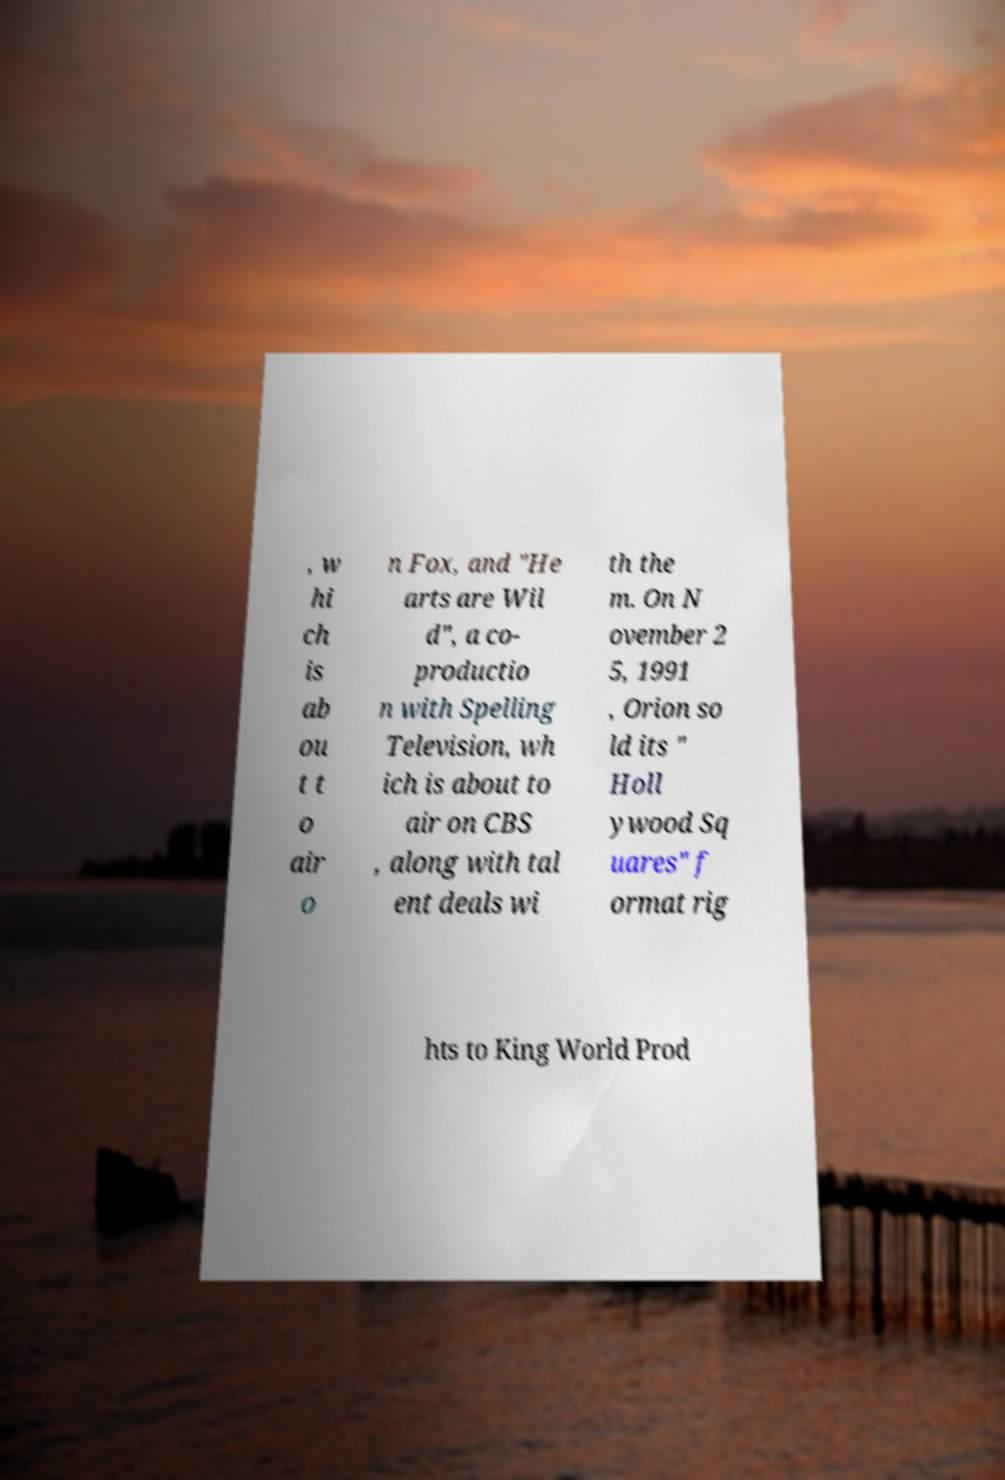Can you accurately transcribe the text from the provided image for me? , w hi ch is ab ou t t o air o n Fox, and "He arts are Wil d", a co- productio n with Spelling Television, wh ich is about to air on CBS , along with tal ent deals wi th the m. On N ovember 2 5, 1991 , Orion so ld its " Holl ywood Sq uares" f ormat rig hts to King World Prod 